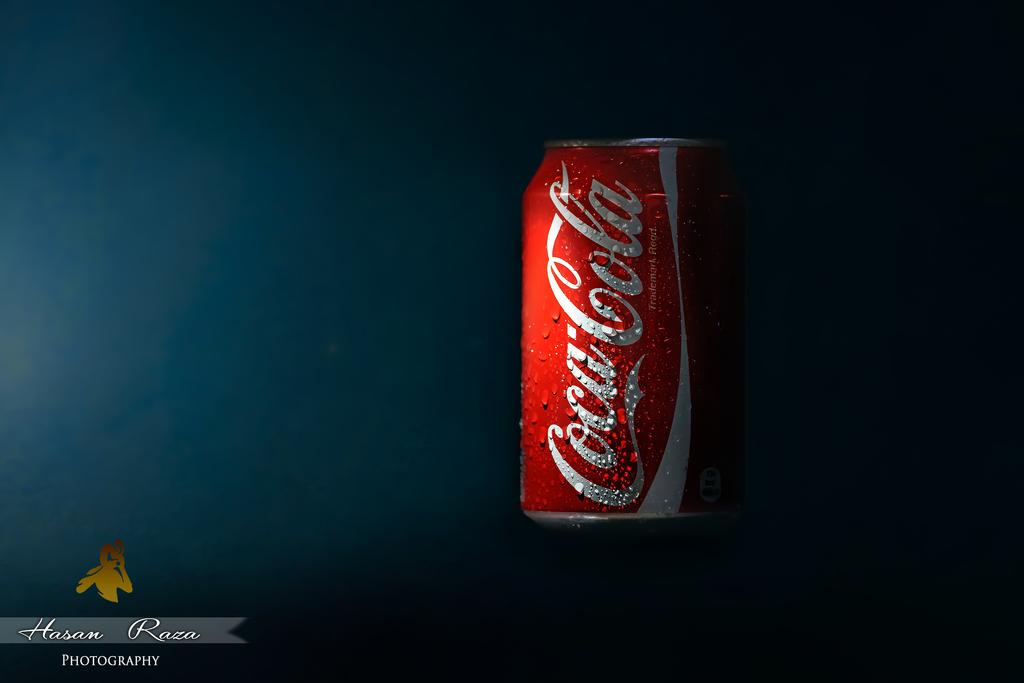What is the main object in the center of the image? There is a beverage tin in the center of the image. Are there any plantations visible in the image? There is no mention of a plantation in the provided facts, and therefore no such location can be observed in the image. Can you see a kitty playing with the beverage tin in the image? There is no kitty present in the image; only the beverage tin is mentioned. 